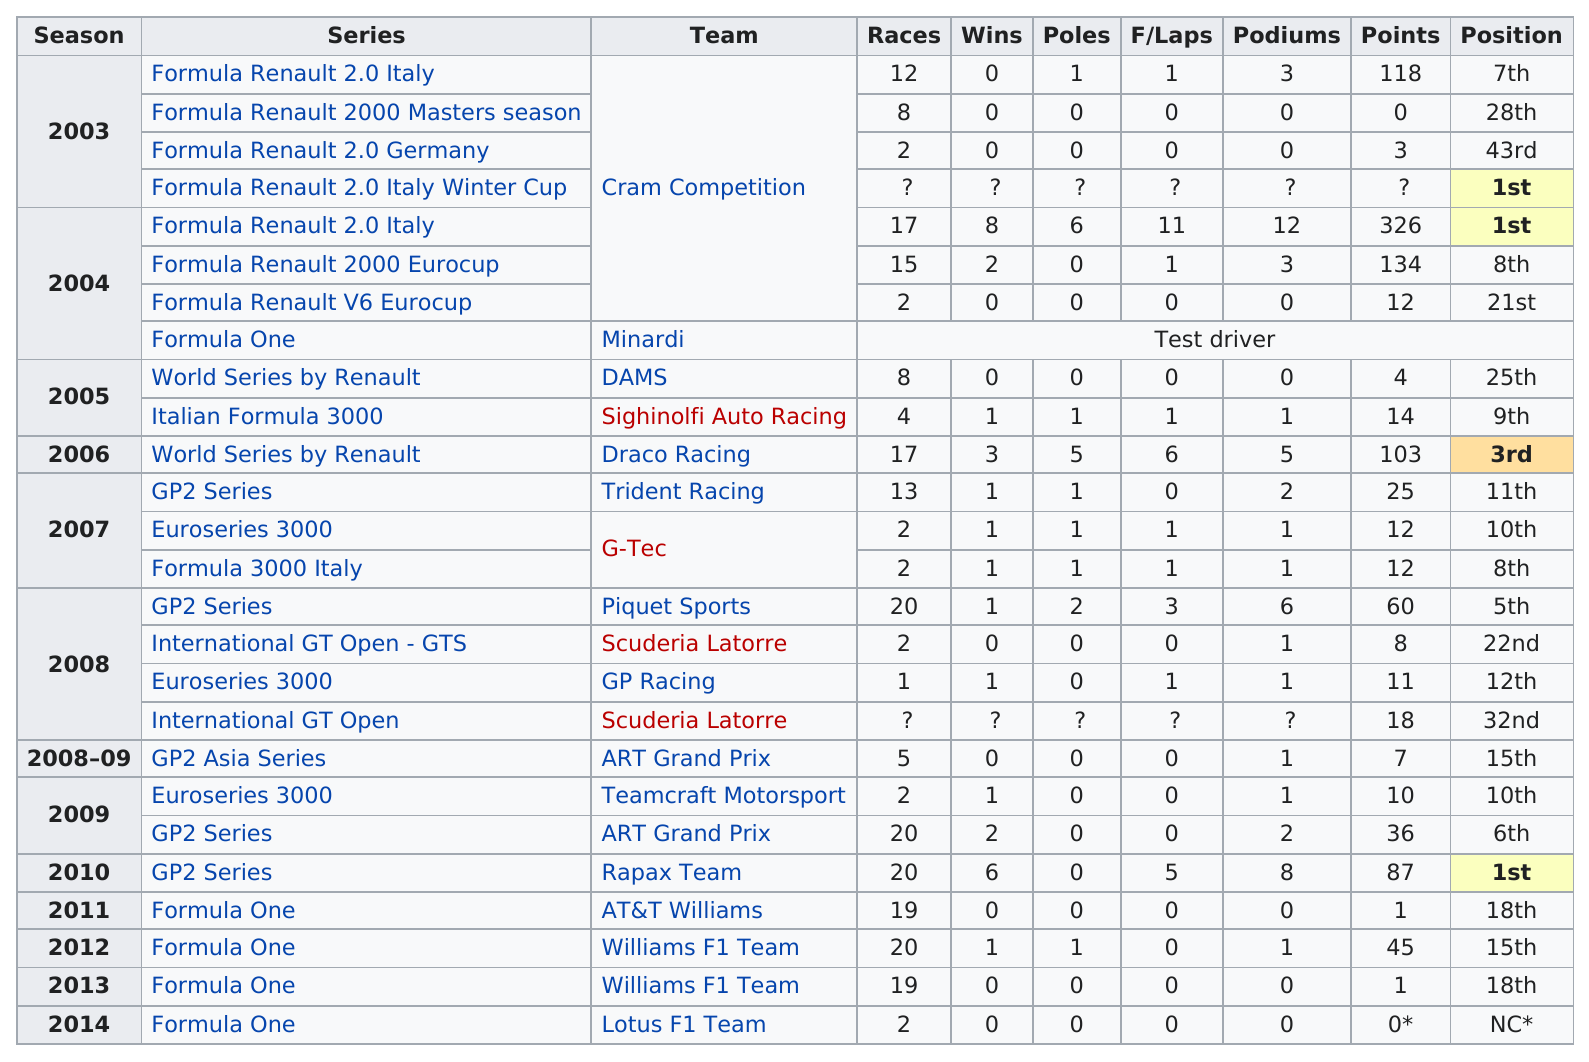Point out several critical features in this image. In 2004, the average number of points scored by [person's name] was 157. Pastor Maldonado has competed with Cram Competition the most out of all the teams he has raced with. The International GT Open was held in 2008, and the race results show that a particular race was the last one held in that year. Pastor Maldonado earned a total of 97 points in races during the year 2008. Pastor Maldonado competed in more races in 2009 than in 2006. 